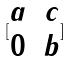<formula> <loc_0><loc_0><loc_500><loc_500>[ \begin{matrix} a & c \\ 0 & b \end{matrix} ]</formula> 